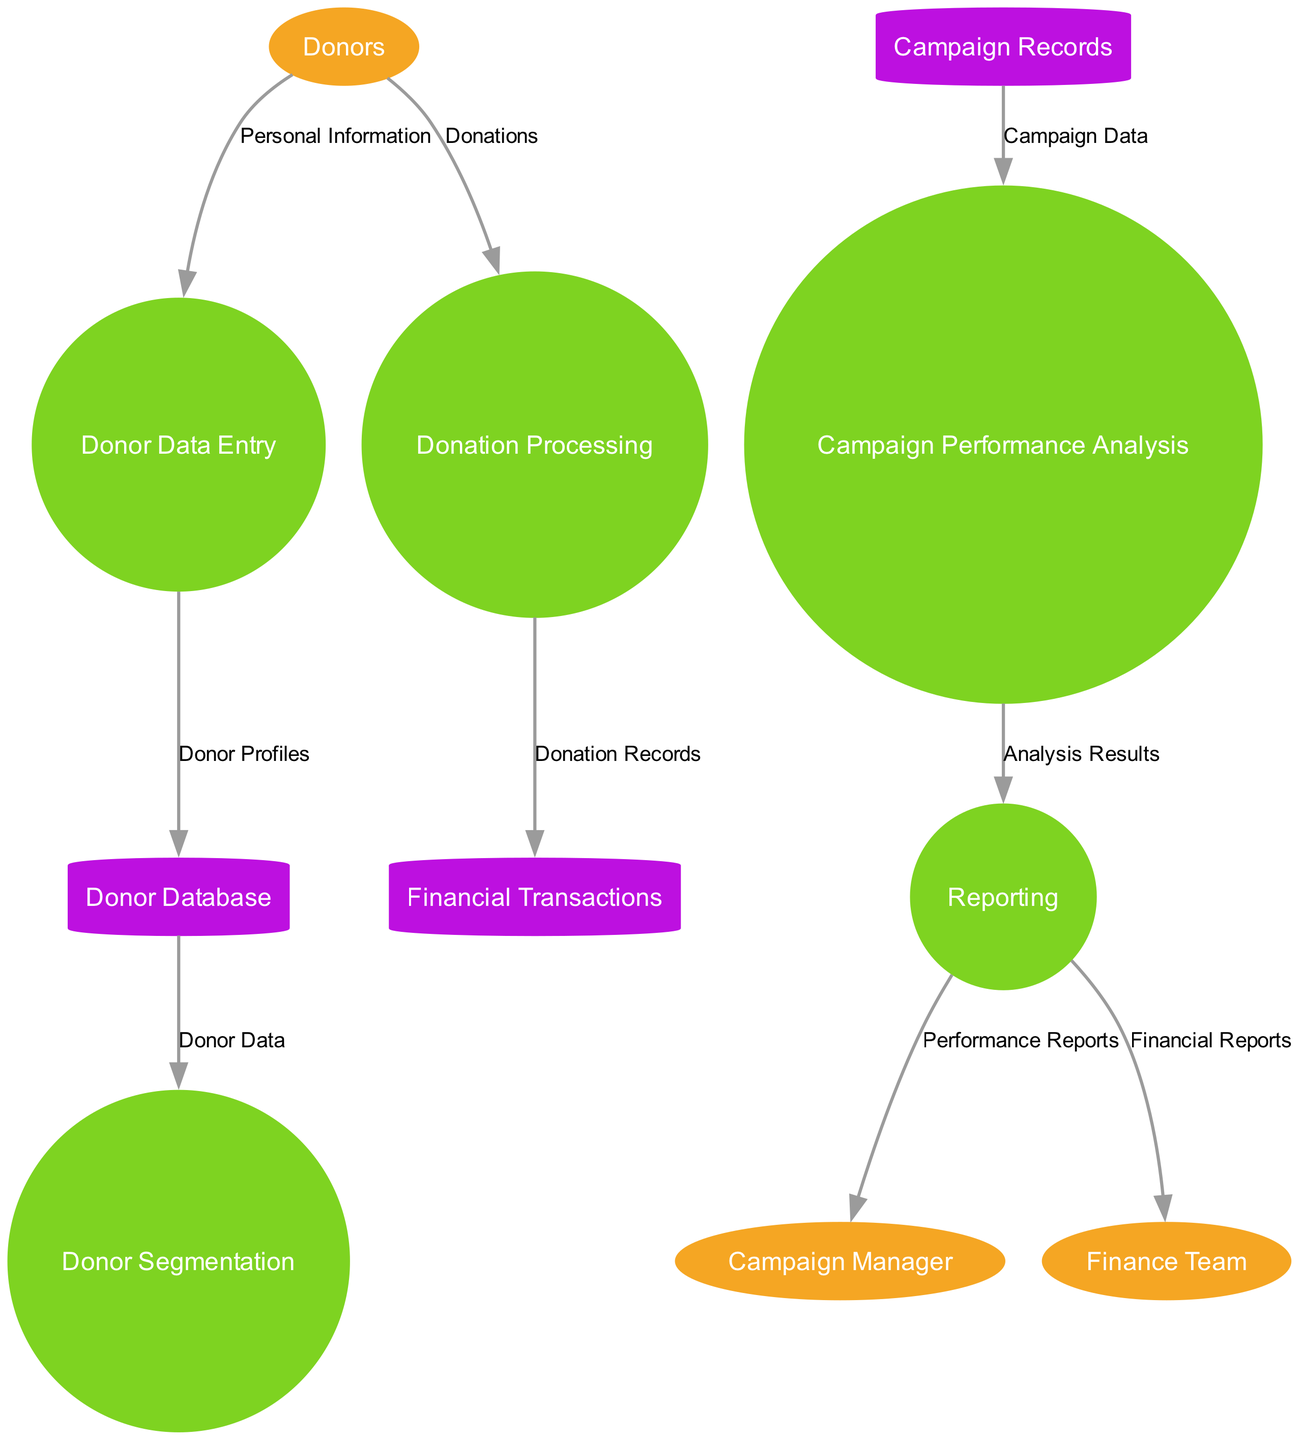What's the total number of external entities in the diagram? The diagram lists three external entities: Donors, Campaign Manager, and Finance Team. Therefore, the total number is 3.
Answer: 3 What data flow comes from Donor Data Entry? The data flow from Donor Data Entry goes into the Donor Database, labeled as "Donor Profiles."
Answer: Donor Profiles Which process receives donations directly from donors? The process that receives donations directly from donors is Donation Processing. This process is linked to donors by a data flow labeled "Donations."
Answer: Donation Processing How many processes are present in the diagram? There are five processes identified in the diagram: Donor Data Entry, Donation Processing, Campaign Performance Analysis, Donor Segmentation, and Reporting. The total count is five.
Answer: 5 What data flow is sent to the Finance Team? The data flow sent to the Finance Team comes from Reporting and is labeled "Financial Reports."
Answer: Financial Reports Which process analyzes the campaign data? The process that analyzes the campaign data is Campaign Performance Analysis. It receives campaign data from Campaign Records.
Answer: Campaign Performance Analysis What type of entity is Donor Database? In the context of this diagram, Donor Database is classified as a data store, indicated by its cylinder shape in the graph and its role in storing donor information.
Answer: Data store How does analysis results flow to the Campaign Manager? The analysis results flow to the Campaign Manager through the Reporting process. Reporting outputs performance reports as a data flow to the Campaign Manager.
Answer: Through Reporting What is the relationship between Donor Segmentation and Donor Database? Donor Segmentation receives Donor Data from the Donor Database, demonstrating a flow of information from the database to the segmentation process.
Answer: Donor Data 